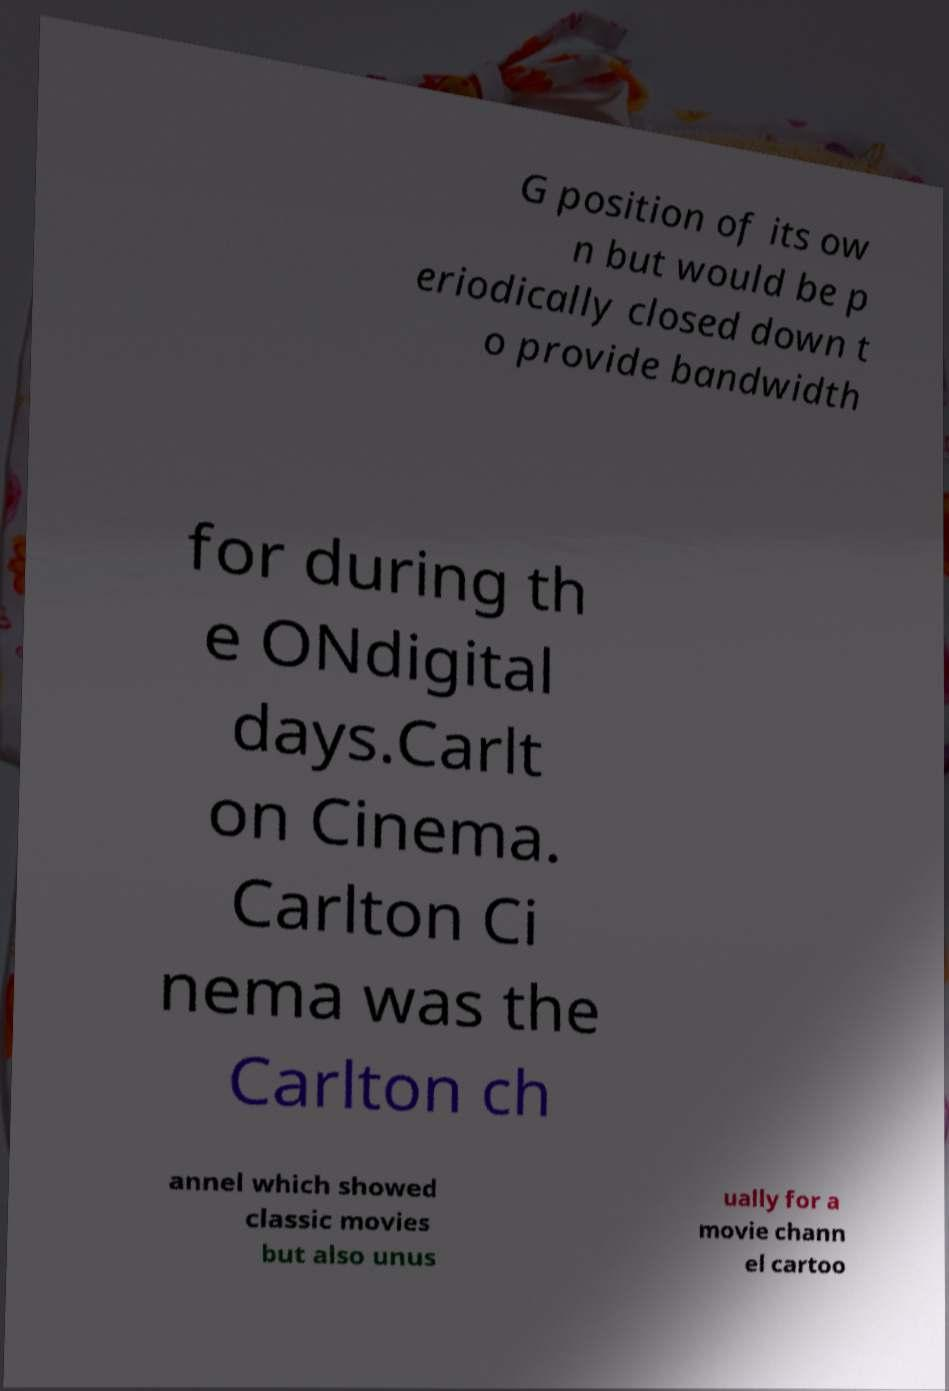Can you read and provide the text displayed in the image?This photo seems to have some interesting text. Can you extract and type it out for me? G position of its ow n but would be p eriodically closed down t o provide bandwidth for during th e ONdigital days.Carlt on Cinema. Carlton Ci nema was the Carlton ch annel which showed classic movies but also unus ually for a movie chann el cartoo 